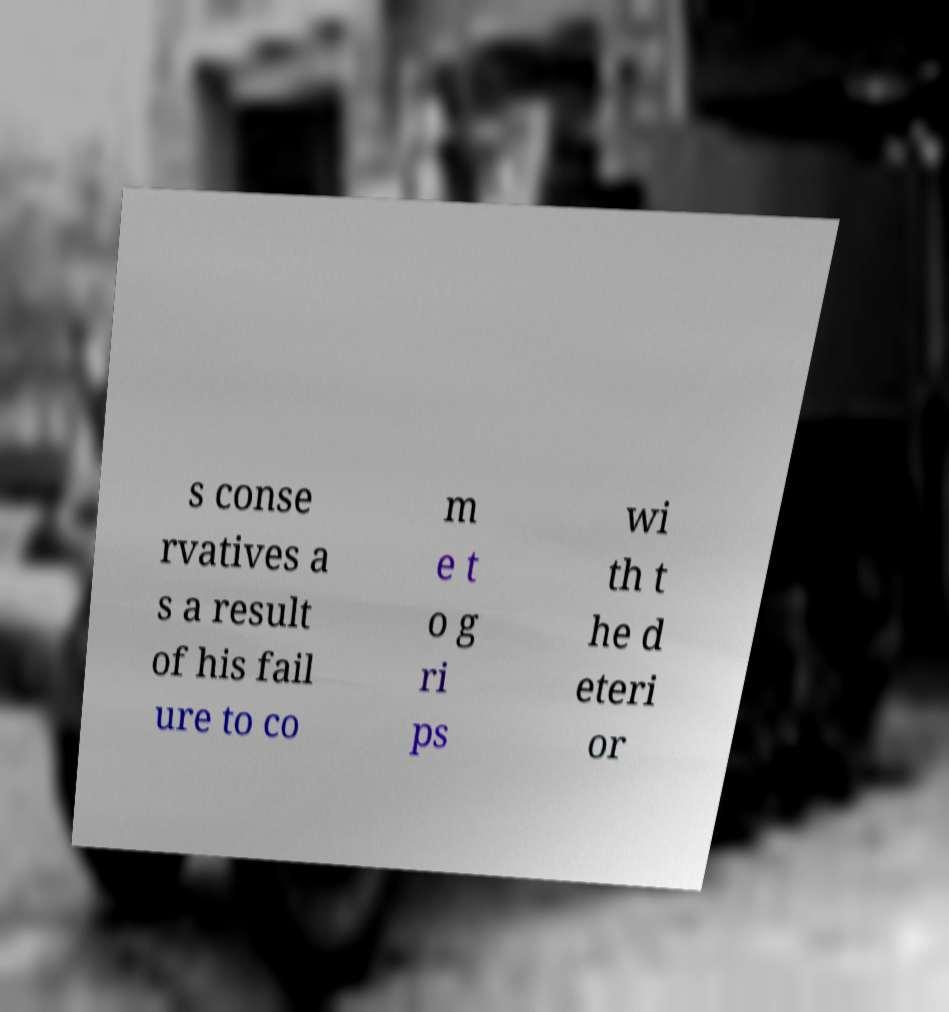Please identify and transcribe the text found in this image. s conse rvatives a s a result of his fail ure to co m e t o g ri ps wi th t he d eteri or 